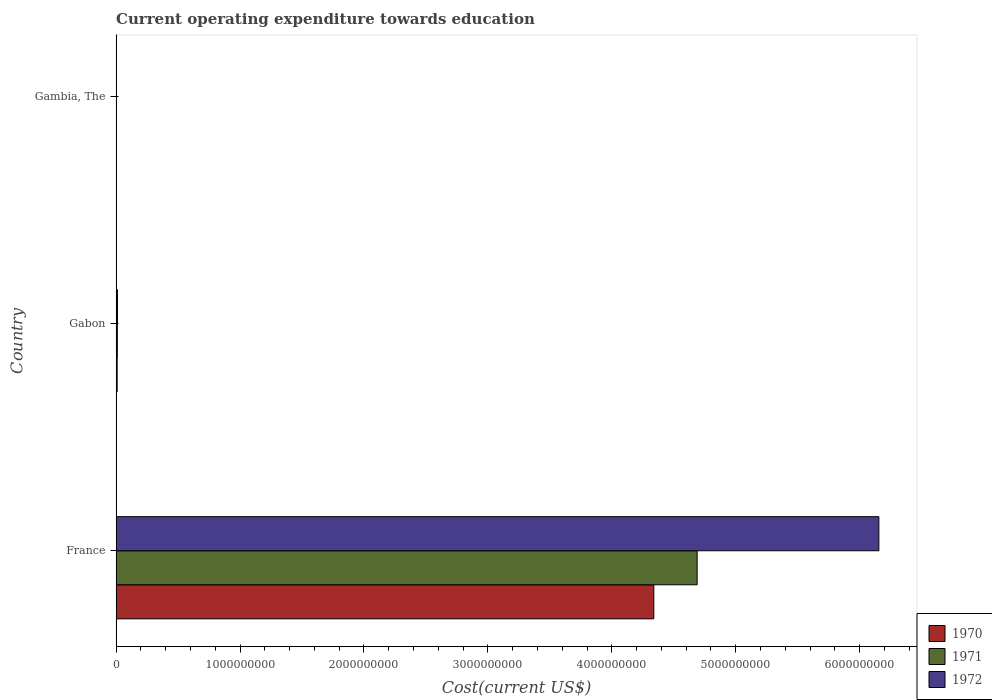How many groups of bars are there?
Ensure brevity in your answer.  3. Are the number of bars per tick equal to the number of legend labels?
Give a very brief answer. Yes. Are the number of bars on each tick of the Y-axis equal?
Your answer should be very brief. Yes. How many bars are there on the 3rd tick from the top?
Make the answer very short. 3. What is the label of the 2nd group of bars from the top?
Ensure brevity in your answer.  Gabon. What is the expenditure towards education in 1971 in Gambia, The?
Your response must be concise. 1.20e+06. Across all countries, what is the maximum expenditure towards education in 1972?
Your response must be concise. 6.16e+09. Across all countries, what is the minimum expenditure towards education in 1971?
Your answer should be very brief. 1.20e+06. In which country was the expenditure towards education in 1972 maximum?
Keep it short and to the point. France. In which country was the expenditure towards education in 1971 minimum?
Give a very brief answer. Gambia, The. What is the total expenditure towards education in 1971 in the graph?
Provide a succinct answer. 4.70e+09. What is the difference between the expenditure towards education in 1970 in Gabon and that in Gambia, The?
Your answer should be compact. 7.14e+06. What is the difference between the expenditure towards education in 1972 in Gabon and the expenditure towards education in 1971 in France?
Give a very brief answer. -4.68e+09. What is the average expenditure towards education in 1970 per country?
Provide a short and direct response. 1.45e+09. What is the difference between the expenditure towards education in 1970 and expenditure towards education in 1972 in Gabon?
Keep it short and to the point. -2.56e+06. In how many countries, is the expenditure towards education in 1970 greater than 2600000000 US$?
Offer a terse response. 1. What is the ratio of the expenditure towards education in 1971 in Gabon to that in Gambia, The?
Offer a terse response. 8.06. Is the difference between the expenditure towards education in 1970 in France and Gabon greater than the difference between the expenditure towards education in 1972 in France and Gabon?
Offer a terse response. No. What is the difference between the highest and the second highest expenditure towards education in 1972?
Give a very brief answer. 6.14e+09. What is the difference between the highest and the lowest expenditure towards education in 1971?
Provide a short and direct response. 4.69e+09. In how many countries, is the expenditure towards education in 1971 greater than the average expenditure towards education in 1971 taken over all countries?
Provide a succinct answer. 1. What does the 2nd bar from the top in France represents?
Offer a very short reply. 1971. What does the 1st bar from the bottom in Gabon represents?
Provide a succinct answer. 1970. Is it the case that in every country, the sum of the expenditure towards education in 1972 and expenditure towards education in 1970 is greater than the expenditure towards education in 1971?
Your answer should be very brief. Yes. How many bars are there?
Ensure brevity in your answer.  9. Does the graph contain grids?
Your answer should be very brief. No. What is the title of the graph?
Your response must be concise. Current operating expenditure towards education. What is the label or title of the X-axis?
Offer a very short reply. Cost(current US$). What is the Cost(current US$) in 1970 in France?
Give a very brief answer. 4.34e+09. What is the Cost(current US$) in 1971 in France?
Your response must be concise. 4.69e+09. What is the Cost(current US$) in 1972 in France?
Your response must be concise. 6.16e+09. What is the Cost(current US$) in 1970 in Gabon?
Provide a succinct answer. 8.29e+06. What is the Cost(current US$) in 1971 in Gabon?
Make the answer very short. 9.66e+06. What is the Cost(current US$) of 1972 in Gabon?
Provide a succinct answer. 1.09e+07. What is the Cost(current US$) in 1970 in Gambia, The?
Give a very brief answer. 1.15e+06. What is the Cost(current US$) of 1971 in Gambia, The?
Keep it short and to the point. 1.20e+06. What is the Cost(current US$) in 1972 in Gambia, The?
Make the answer very short. 1.44e+06. Across all countries, what is the maximum Cost(current US$) in 1970?
Provide a short and direct response. 4.34e+09. Across all countries, what is the maximum Cost(current US$) of 1971?
Offer a very short reply. 4.69e+09. Across all countries, what is the maximum Cost(current US$) in 1972?
Make the answer very short. 6.16e+09. Across all countries, what is the minimum Cost(current US$) of 1970?
Ensure brevity in your answer.  1.15e+06. Across all countries, what is the minimum Cost(current US$) in 1971?
Make the answer very short. 1.20e+06. Across all countries, what is the minimum Cost(current US$) in 1972?
Provide a succinct answer. 1.44e+06. What is the total Cost(current US$) of 1970 in the graph?
Offer a terse response. 4.35e+09. What is the total Cost(current US$) of 1971 in the graph?
Your answer should be very brief. 4.70e+09. What is the total Cost(current US$) of 1972 in the graph?
Offer a terse response. 6.17e+09. What is the difference between the Cost(current US$) of 1970 in France and that in Gabon?
Give a very brief answer. 4.33e+09. What is the difference between the Cost(current US$) of 1971 in France and that in Gabon?
Make the answer very short. 4.68e+09. What is the difference between the Cost(current US$) of 1972 in France and that in Gabon?
Your answer should be very brief. 6.14e+09. What is the difference between the Cost(current US$) of 1970 in France and that in Gambia, The?
Provide a succinct answer. 4.34e+09. What is the difference between the Cost(current US$) of 1971 in France and that in Gambia, The?
Offer a terse response. 4.69e+09. What is the difference between the Cost(current US$) in 1972 in France and that in Gambia, The?
Offer a terse response. 6.15e+09. What is the difference between the Cost(current US$) in 1970 in Gabon and that in Gambia, The?
Your answer should be very brief. 7.14e+06. What is the difference between the Cost(current US$) in 1971 in Gabon and that in Gambia, The?
Your answer should be compact. 8.46e+06. What is the difference between the Cost(current US$) in 1972 in Gabon and that in Gambia, The?
Keep it short and to the point. 9.41e+06. What is the difference between the Cost(current US$) of 1970 in France and the Cost(current US$) of 1971 in Gabon?
Keep it short and to the point. 4.33e+09. What is the difference between the Cost(current US$) of 1970 in France and the Cost(current US$) of 1972 in Gabon?
Offer a terse response. 4.33e+09. What is the difference between the Cost(current US$) in 1971 in France and the Cost(current US$) in 1972 in Gabon?
Your answer should be compact. 4.68e+09. What is the difference between the Cost(current US$) in 1970 in France and the Cost(current US$) in 1971 in Gambia, The?
Your answer should be very brief. 4.34e+09. What is the difference between the Cost(current US$) of 1970 in France and the Cost(current US$) of 1972 in Gambia, The?
Ensure brevity in your answer.  4.34e+09. What is the difference between the Cost(current US$) in 1971 in France and the Cost(current US$) in 1972 in Gambia, The?
Ensure brevity in your answer.  4.69e+09. What is the difference between the Cost(current US$) in 1970 in Gabon and the Cost(current US$) in 1971 in Gambia, The?
Ensure brevity in your answer.  7.10e+06. What is the difference between the Cost(current US$) of 1970 in Gabon and the Cost(current US$) of 1972 in Gambia, The?
Ensure brevity in your answer.  6.85e+06. What is the difference between the Cost(current US$) of 1971 in Gabon and the Cost(current US$) of 1972 in Gambia, The?
Keep it short and to the point. 8.22e+06. What is the average Cost(current US$) of 1970 per country?
Your response must be concise. 1.45e+09. What is the average Cost(current US$) of 1971 per country?
Your response must be concise. 1.57e+09. What is the average Cost(current US$) in 1972 per country?
Your response must be concise. 2.06e+09. What is the difference between the Cost(current US$) of 1970 and Cost(current US$) of 1971 in France?
Ensure brevity in your answer.  -3.50e+08. What is the difference between the Cost(current US$) of 1970 and Cost(current US$) of 1972 in France?
Provide a succinct answer. -1.82e+09. What is the difference between the Cost(current US$) in 1971 and Cost(current US$) in 1972 in France?
Your response must be concise. -1.47e+09. What is the difference between the Cost(current US$) in 1970 and Cost(current US$) in 1971 in Gabon?
Provide a succinct answer. -1.37e+06. What is the difference between the Cost(current US$) of 1970 and Cost(current US$) of 1972 in Gabon?
Offer a very short reply. -2.56e+06. What is the difference between the Cost(current US$) in 1971 and Cost(current US$) in 1972 in Gabon?
Ensure brevity in your answer.  -1.19e+06. What is the difference between the Cost(current US$) of 1970 and Cost(current US$) of 1971 in Gambia, The?
Your answer should be very brief. -4.75e+04. What is the difference between the Cost(current US$) in 1970 and Cost(current US$) in 1972 in Gambia, The?
Offer a terse response. -2.88e+05. What is the difference between the Cost(current US$) in 1971 and Cost(current US$) in 1972 in Gambia, The?
Offer a very short reply. -2.40e+05. What is the ratio of the Cost(current US$) in 1970 in France to that in Gabon?
Give a very brief answer. 523.2. What is the ratio of the Cost(current US$) of 1971 in France to that in Gabon?
Offer a very short reply. 485.47. What is the ratio of the Cost(current US$) of 1972 in France to that in Gabon?
Your answer should be compact. 567.19. What is the ratio of the Cost(current US$) in 1970 in France to that in Gambia, The?
Keep it short and to the point. 3771.39. What is the ratio of the Cost(current US$) in 1971 in France to that in Gambia, The?
Give a very brief answer. 3913.76. What is the ratio of the Cost(current US$) of 1972 in France to that in Gambia, The?
Your answer should be compact. 4278.91. What is the ratio of the Cost(current US$) in 1970 in Gabon to that in Gambia, The?
Keep it short and to the point. 7.21. What is the ratio of the Cost(current US$) of 1971 in Gabon to that in Gambia, The?
Offer a terse response. 8.06. What is the ratio of the Cost(current US$) in 1972 in Gabon to that in Gambia, The?
Make the answer very short. 7.54. What is the difference between the highest and the second highest Cost(current US$) of 1970?
Your answer should be compact. 4.33e+09. What is the difference between the highest and the second highest Cost(current US$) in 1971?
Ensure brevity in your answer.  4.68e+09. What is the difference between the highest and the second highest Cost(current US$) of 1972?
Your answer should be very brief. 6.14e+09. What is the difference between the highest and the lowest Cost(current US$) of 1970?
Keep it short and to the point. 4.34e+09. What is the difference between the highest and the lowest Cost(current US$) of 1971?
Keep it short and to the point. 4.69e+09. What is the difference between the highest and the lowest Cost(current US$) in 1972?
Your response must be concise. 6.15e+09. 